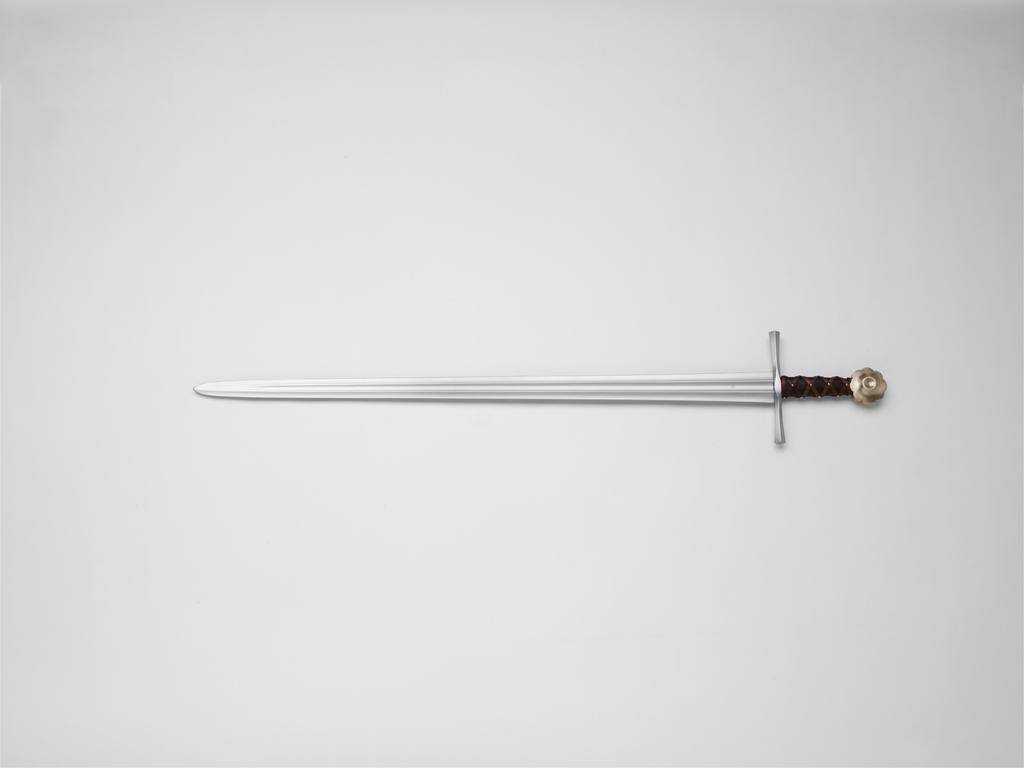In one or two sentences, can you explain what this image depicts? In the image there is a sword kept on a surface. 